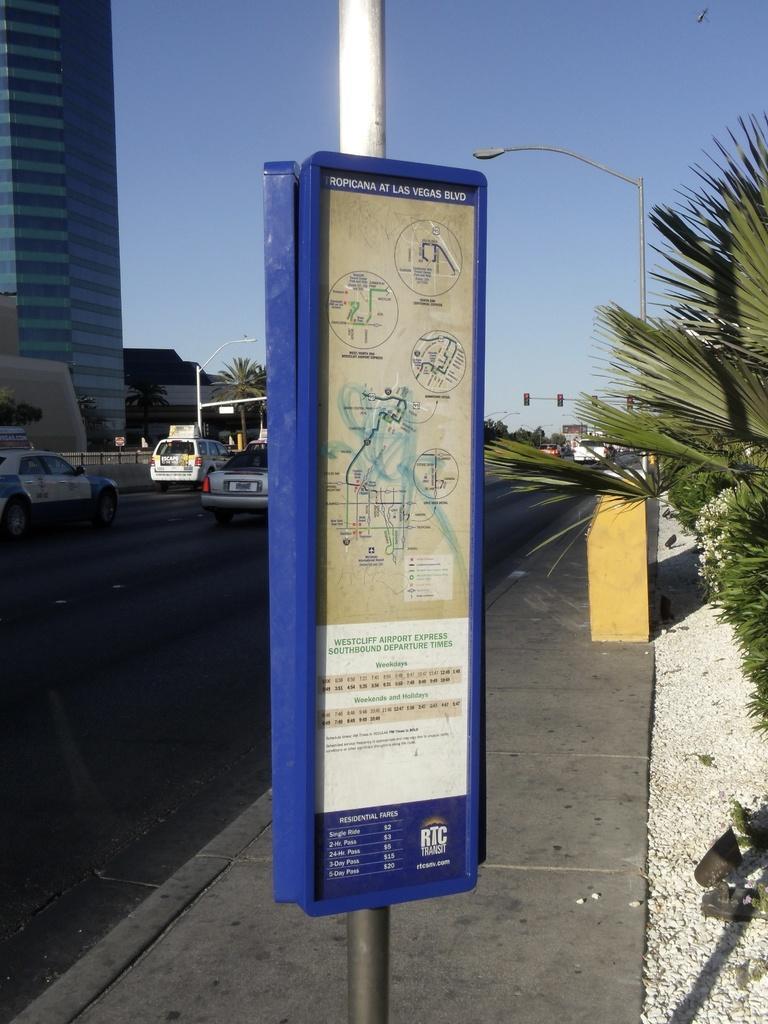Please provide a concise description of this image. In this image I can see few poles, few lights, trees, road, number of vehicles, few buildings and in background I can see the sky. Here on this board I can see something is written. 